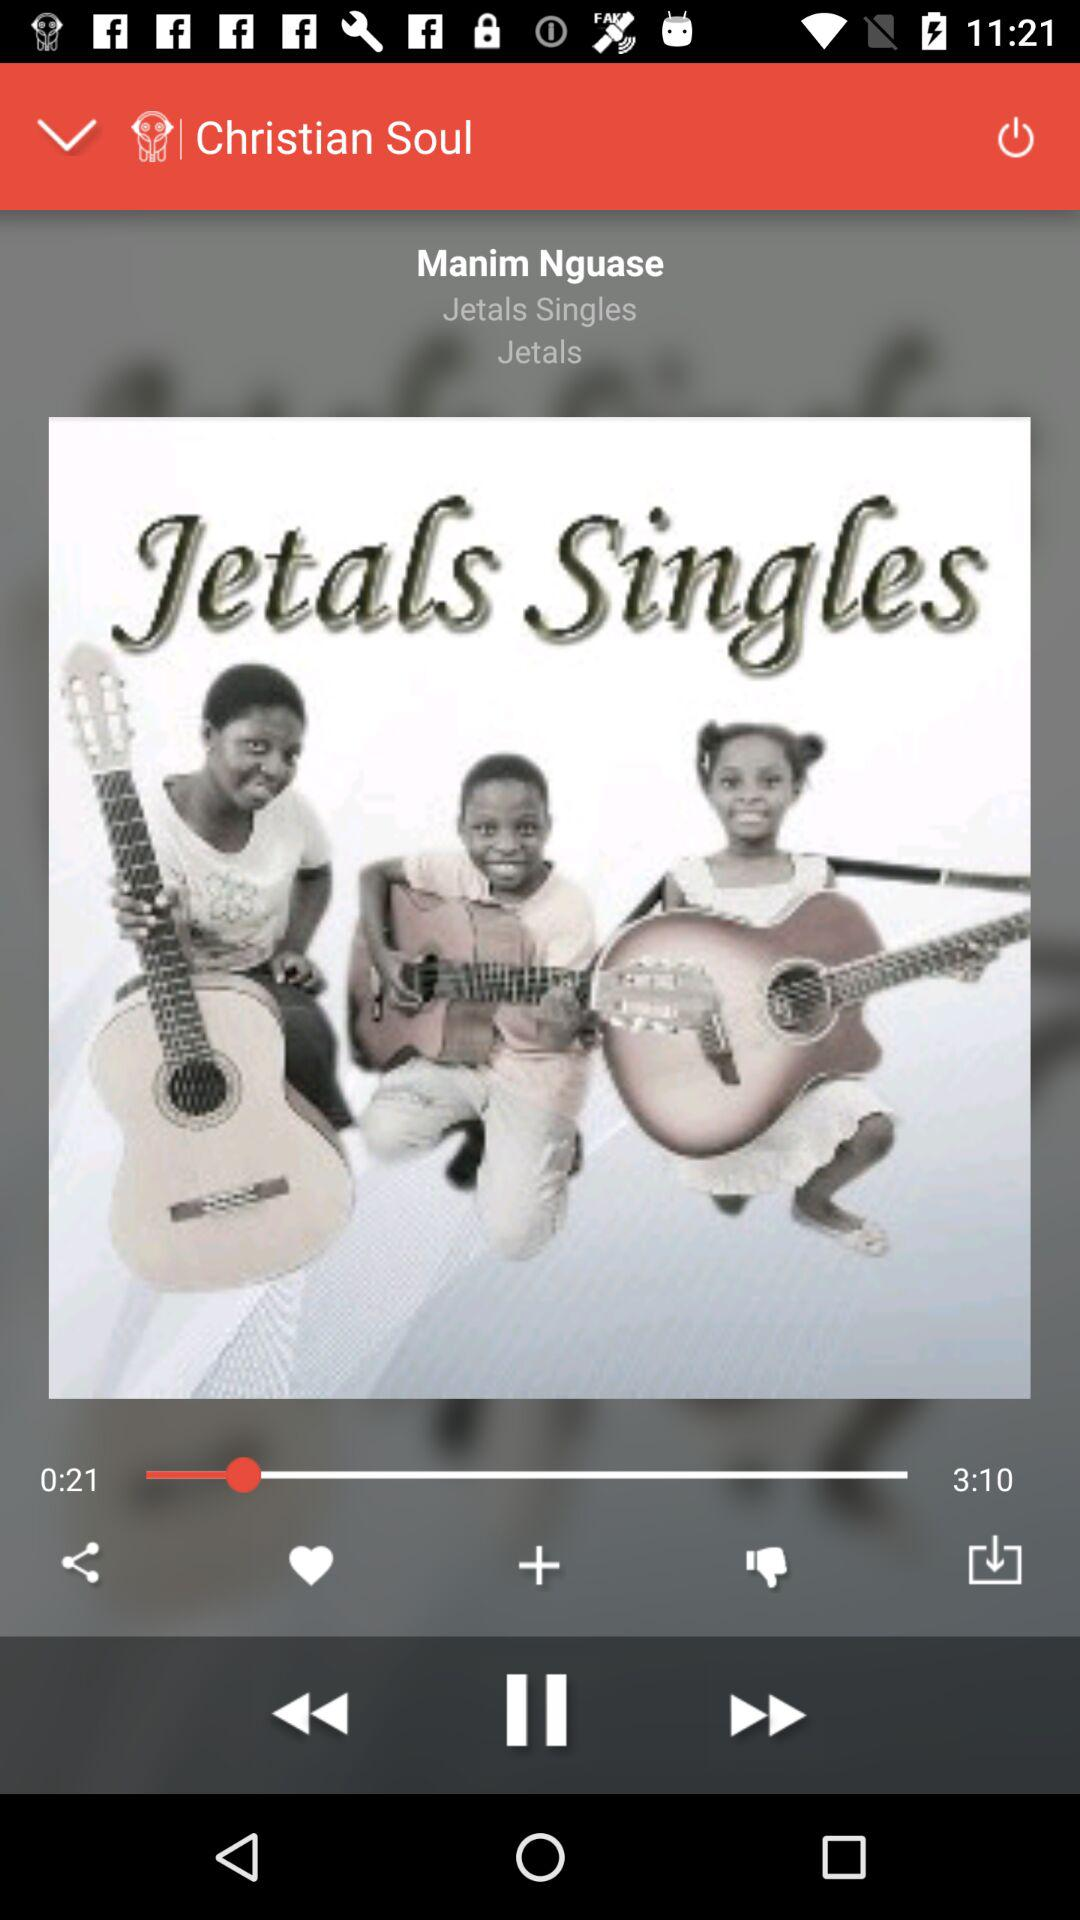Who's the singer? The singer is "Manim Nguase". 